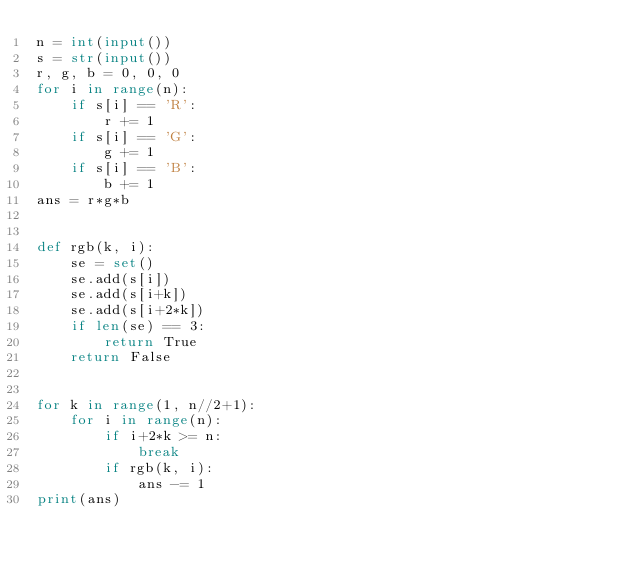<code> <loc_0><loc_0><loc_500><loc_500><_Python_>n = int(input())
s = str(input())
r, g, b = 0, 0, 0
for i in range(n):
    if s[i] == 'R':
        r += 1
    if s[i] == 'G':
        g += 1
    if s[i] == 'B':
        b += 1
ans = r*g*b


def rgb(k, i):
    se = set()
    se.add(s[i])
    se.add(s[i+k])
    se.add(s[i+2*k])
    if len(se) == 3:
        return True
    return False


for k in range(1, n//2+1):
    for i in range(n):
        if i+2*k >= n:
            break
        if rgb(k, i):
            ans -= 1
print(ans)
</code> 